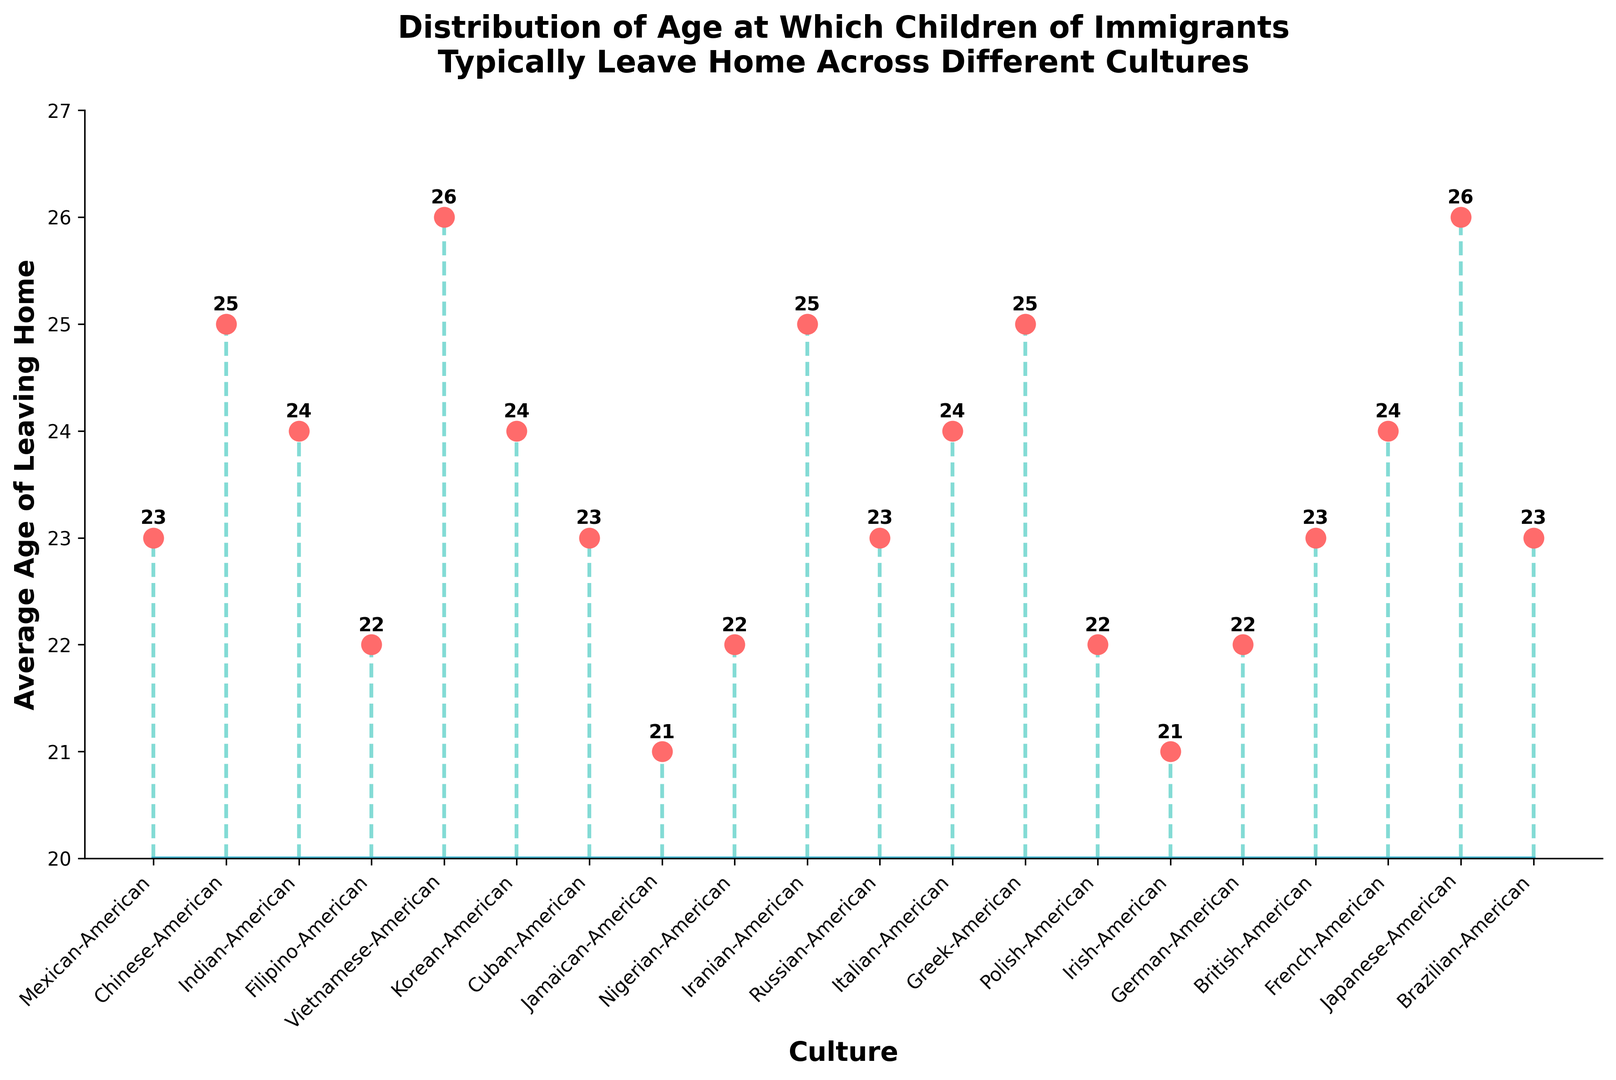Which culture has the highest average age at which children leave home? The data shows the average age for each culture. Vietnamese-American and Japanese-American stand out with an average age of 26.
Answer: Vietnamese-American and Japanese-American Which culture has the lowest average age at which children leave home? Checking the average ages, Jamaican-American and Irish-American cultures have the lowest at 21.
Answer: Jamaican-American and Irish-American What is the average age difference between Chinese-American and Filipino-American children leaving home? Subtract the average age of Filipino-American (22) from Chinese-American (25). 25 - 22 = 3.
Answer: 3 What is the median average age of leaving home in this dataset? Arrange the average ages in numerical order and find the middle value. The ordered ages are: 21, 21, 22, 22, 22, 23, 23, 23, 23, 23, 24, 24, 24, 24, 25, 25, 25, 25, 26, 26. The middle values are 23 and 24, so the median is (23 + 24) / 2 = 23.5.
Answer: 23.5 Among Indian-American, Korean-American, and Italian-American, which culture has the youngest average age for children leaving home? Comparing the average ages: Indian-American (24), Korean-American (24), Italian-American (24). All have the same average age.
Answer: All have the same age How many cultures have children leaving home at an average age of 25 or older? From the data, the cultures with average ages 25 or older are: Chinese-American (25), Vietnamese-American (26), Iranian-American (25), Greek-American (25), Japanese-American (26). There are 5 such cultures.
Answer: 5 What is the range of ages at which children leave home across different cultures? The lowest average age is 21 (Jamaican-American, Irish-American) and the highest is 26 (Vietnamese-American, Japanese-American). The range is 26 - 21 = 5.
Answer: 5 Between Nigerian-American and Polish-American cultures, which one has children leaving home at an older average age? Comparing the average ages: Nigerian-American (22), Polish-American (22). Both have the same average age.
Answer: Both are the same If you combine the Mexican-American, Cuban-American, and Brazilian-American cultures, what is their combined average age of leaving home? Add the average ages and divide by the number of cultures: (23 + 23 + 23) / 3 = 69 / 3 = 23.
Answer: 23 What is the total number of cultures where the average age of leaving home is exactly 24? The cultures with an average age of 24 are Indian-American, Korean-American, Italian-American, French-American. There are 4 such cultures.
Answer: 4 